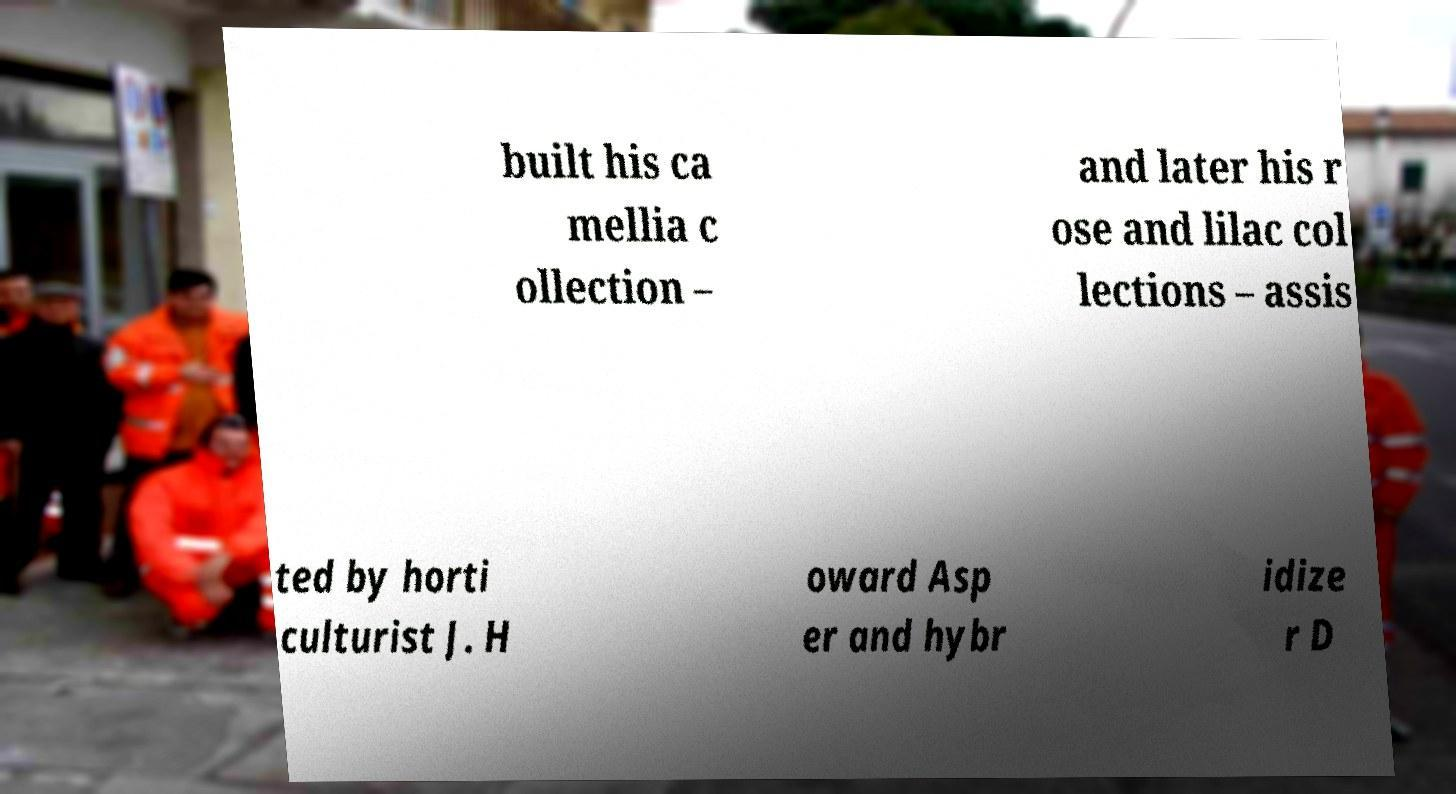Can you read and provide the text displayed in the image?This photo seems to have some interesting text. Can you extract and type it out for me? built his ca mellia c ollection – and later his r ose and lilac col lections – assis ted by horti culturist J. H oward Asp er and hybr idize r D 